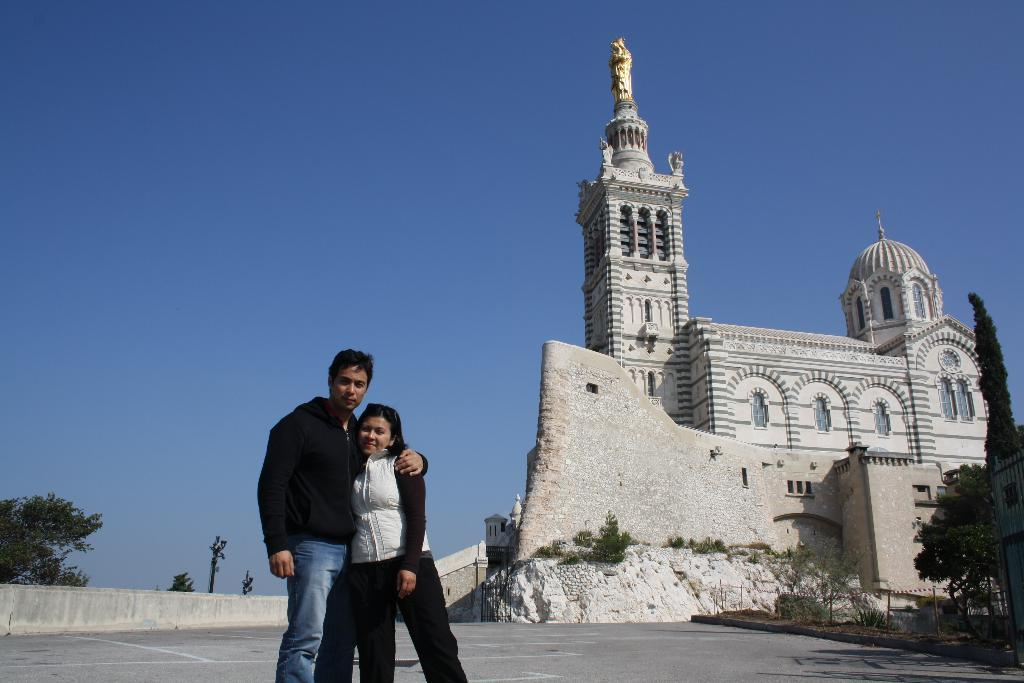How many people are in the image? There are two persons standing in the center of the image. What can be seen in the background of the image? There is a church and trees in the background of the image. What decision did the slave make in the image? There is no mention of a slave or any decision-making in the image. 